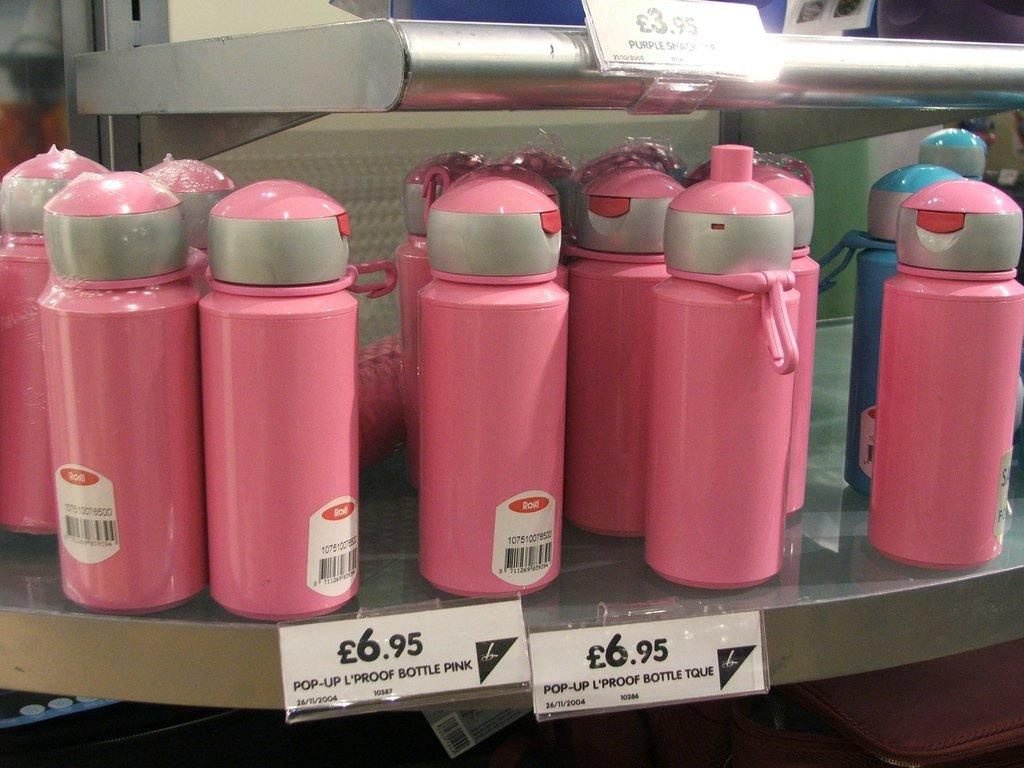What objects can be seen in the image? There are bottles in the image. Are there any additional details about the bottles? Yes, there are price tags in the image. What type of committee is responsible for the pricing of the bottles in the image? There is no committee mentioned or implied in the image, and the pricing is indicated by the presence of price tags. 